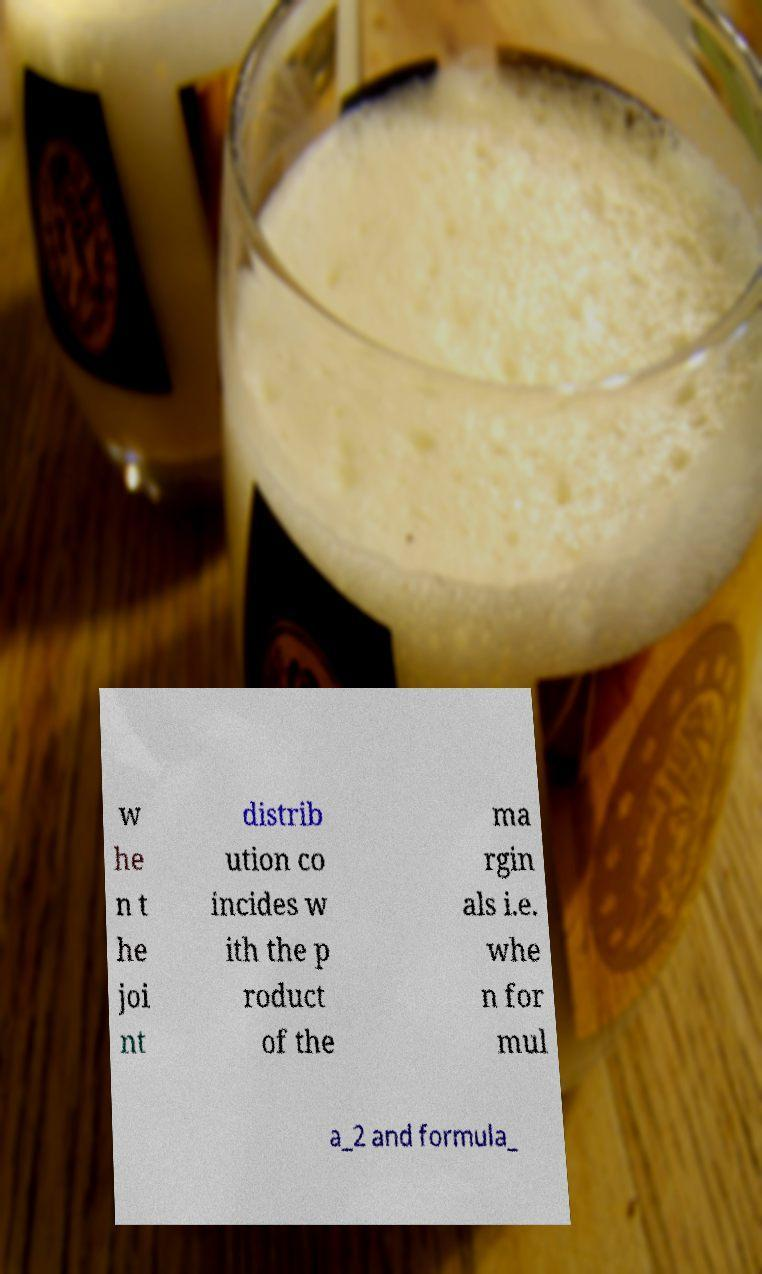What messages or text are displayed in this image? I need them in a readable, typed format. w he n t he joi nt distrib ution co incides w ith the p roduct of the ma rgin als i.e. whe n for mul a_2 and formula_ 